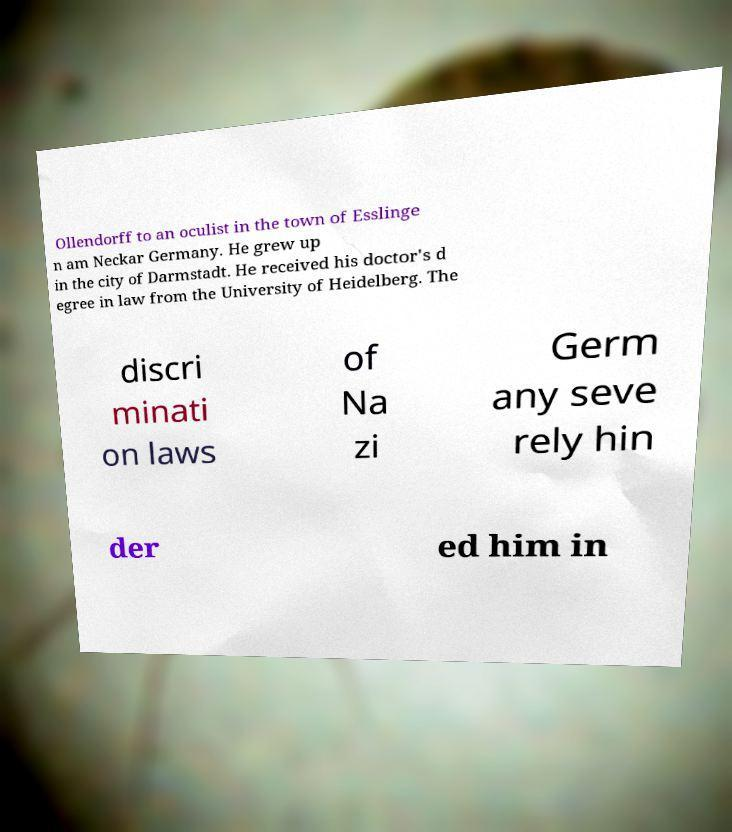I need the written content from this picture converted into text. Can you do that? Ollendorff to an oculist in the town of Esslinge n am Neckar Germany. He grew up in the city of Darmstadt. He received his doctor's d egree in law from the University of Heidelberg. The discri minati on laws of Na zi Germ any seve rely hin der ed him in 